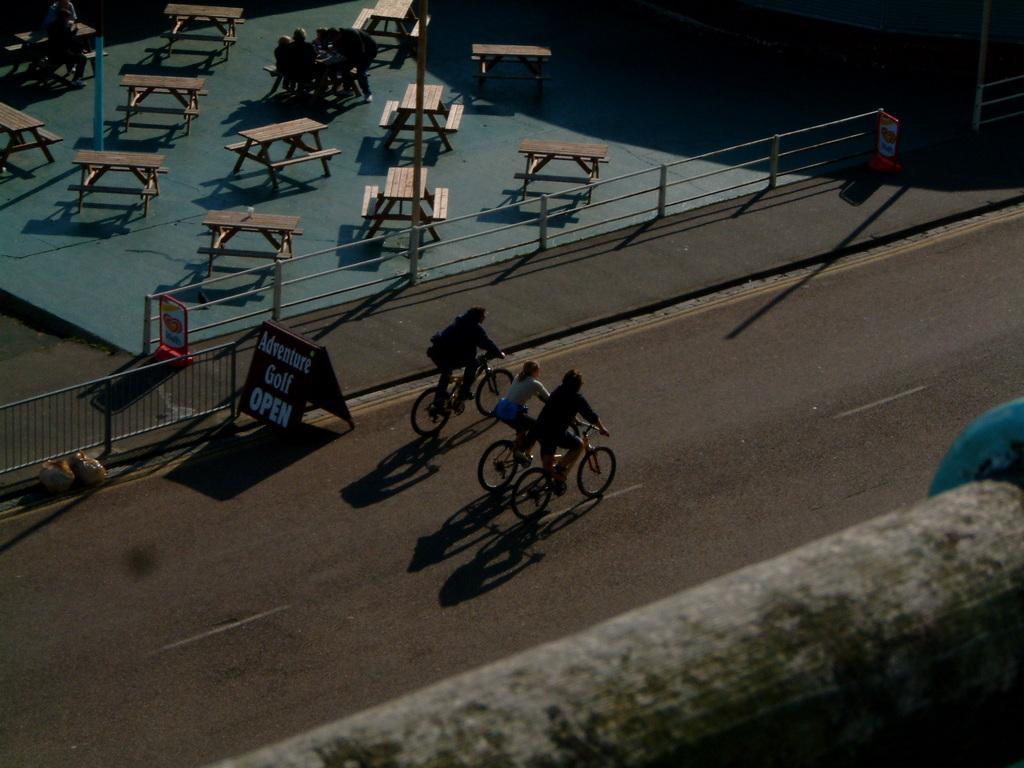Can you describe this image briefly? In this image we can see three persons riding bicycles. Behind the persons we can see barriers, tables and boards. On the boards we can see some text. At the top we can see few persons near the table. At the bottom we can see a wall. 